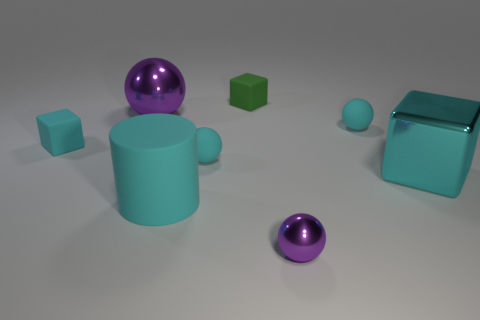Do the matte thing on the left side of the cyan rubber cylinder and the cylinder have the same size? If you're referring to the matte object as the green cube on the left of the image, it does not have the same size as the cyan cylinder. The green cube appears smaller in comparison to the cyan cylinder's height and diameter. 